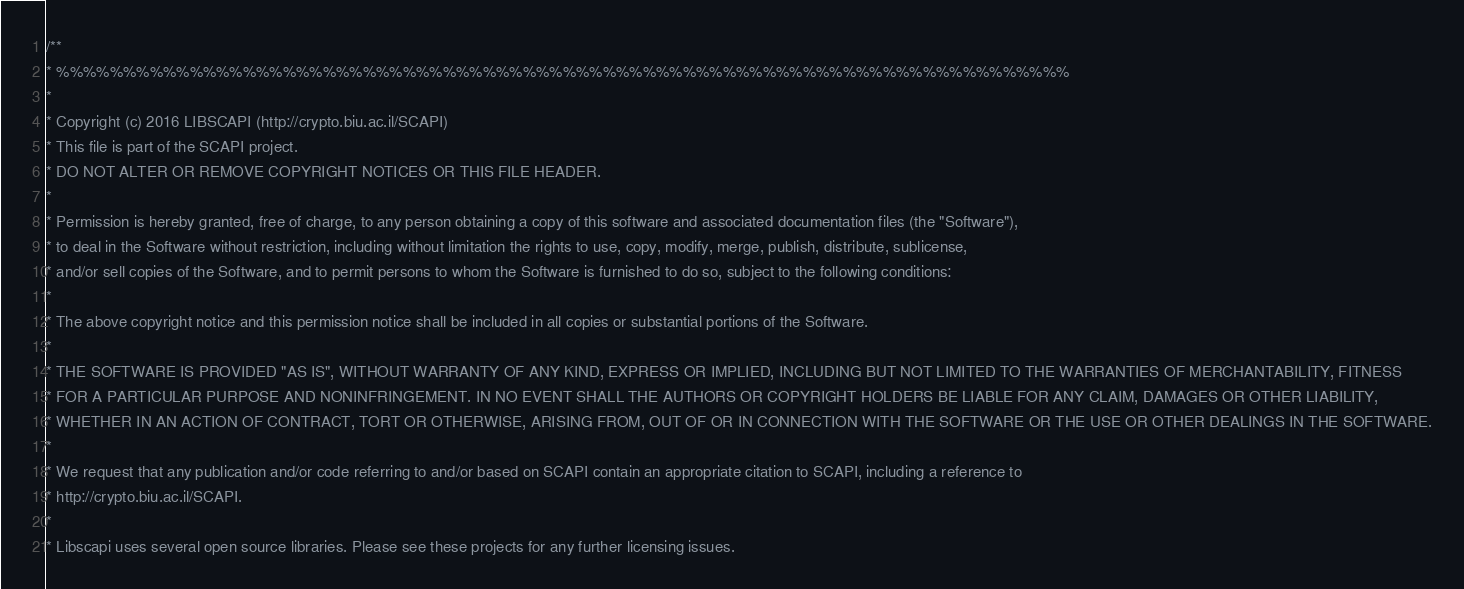Convert code to text. <code><loc_0><loc_0><loc_500><loc_500><_C++_>/**
* %%%%%%%%%%%%%%%%%%%%%%%%%%%%%%%%%%%%%%%%%%%%%%%%%%%%%%%%%%%%%%%%%%%%%%%%%%%%
* 
* Copyright (c) 2016 LIBSCAPI (http://crypto.biu.ac.il/SCAPI)
* This file is part of the SCAPI project.
* DO NOT ALTER OR REMOVE COPYRIGHT NOTICES OR THIS FILE HEADER.
* 
* Permission is hereby granted, free of charge, to any person obtaining a copy of this software and associated documentation files (the "Software"),
* to deal in the Software without restriction, including without limitation the rights to use, copy, modify, merge, publish, distribute, sublicense, 
* and/or sell copies of the Software, and to permit persons to whom the Software is furnished to do so, subject to the following conditions:
* 
* The above copyright notice and this permission notice shall be included in all copies or substantial portions of the Software.
* 
* THE SOFTWARE IS PROVIDED "AS IS", WITHOUT WARRANTY OF ANY KIND, EXPRESS OR IMPLIED, INCLUDING BUT NOT LIMITED TO THE WARRANTIES OF MERCHANTABILITY, FITNESS
* FOR A PARTICULAR PURPOSE AND NONINFRINGEMENT. IN NO EVENT SHALL THE AUTHORS OR COPYRIGHT HOLDERS BE LIABLE FOR ANY CLAIM, DAMAGES OR OTHER LIABILITY,
* WHETHER IN AN ACTION OF CONTRACT, TORT OR OTHERWISE, ARISING FROM, OUT OF OR IN CONNECTION WITH THE SOFTWARE OR THE USE OR OTHER DEALINGS IN THE SOFTWARE.
* 
* We request that any publication and/or code referring to and/or based on SCAPI contain an appropriate citation to SCAPI, including a reference to
* http://crypto.biu.ac.il/SCAPI.
* 
* Libscapi uses several open source libraries. Please see these projects for any further licensing issues.</code> 